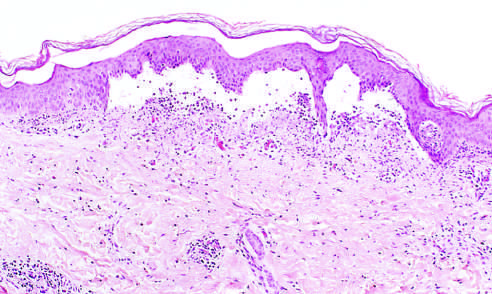what does the low-power view of a cross section of a skin blister show?
Answer the question using a single word or phrase. The epidermis separated from the dermis by a focal collection serous effusion 